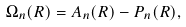<formula> <loc_0><loc_0><loc_500><loc_500>\Omega _ { n } ( { R } ) = { A } _ { n } ( { R } ) - { P } _ { n } ( { R } ) ,</formula> 